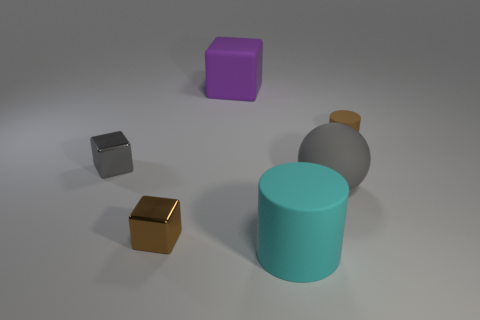Is there any other thing that is the same shape as the tiny brown shiny thing? Yes, the shape of the tiny brown object resembles that of the larger grey object in the background. Both appear to be simple three-dimensional shapes with a cube-like structure. 